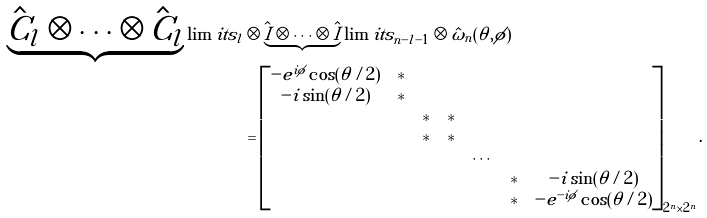<formula> <loc_0><loc_0><loc_500><loc_500>\underbrace { \hat { C } _ { l } \otimes \cdots \otimes \hat { C } _ { l } } \lim i t s _ { l } & \otimes \underbrace { \hat { I } \otimes \cdots \otimes \hat { I } } \lim i t s _ { n - l - 1 } \otimes \hat { \omega } _ { n } ( \theta , \phi ) \\ & = \begin{bmatrix} - e ^ { i \phi } \cos ( \theta / 2 ) & * & & & & & \\ - i \sin ( \theta / 2 ) & * & & & & & \\ & & * & * & & & \\ & & * & * & & & \\ & & & & \cdots & & \\ & & & & & * & - i \sin ( \theta / 2 ) \\ & & & & & * & - e ^ { - i \phi } \cos ( \theta / 2 ) \end{bmatrix} _ { 2 ^ { n } \times 2 ^ { n } } .</formula> 